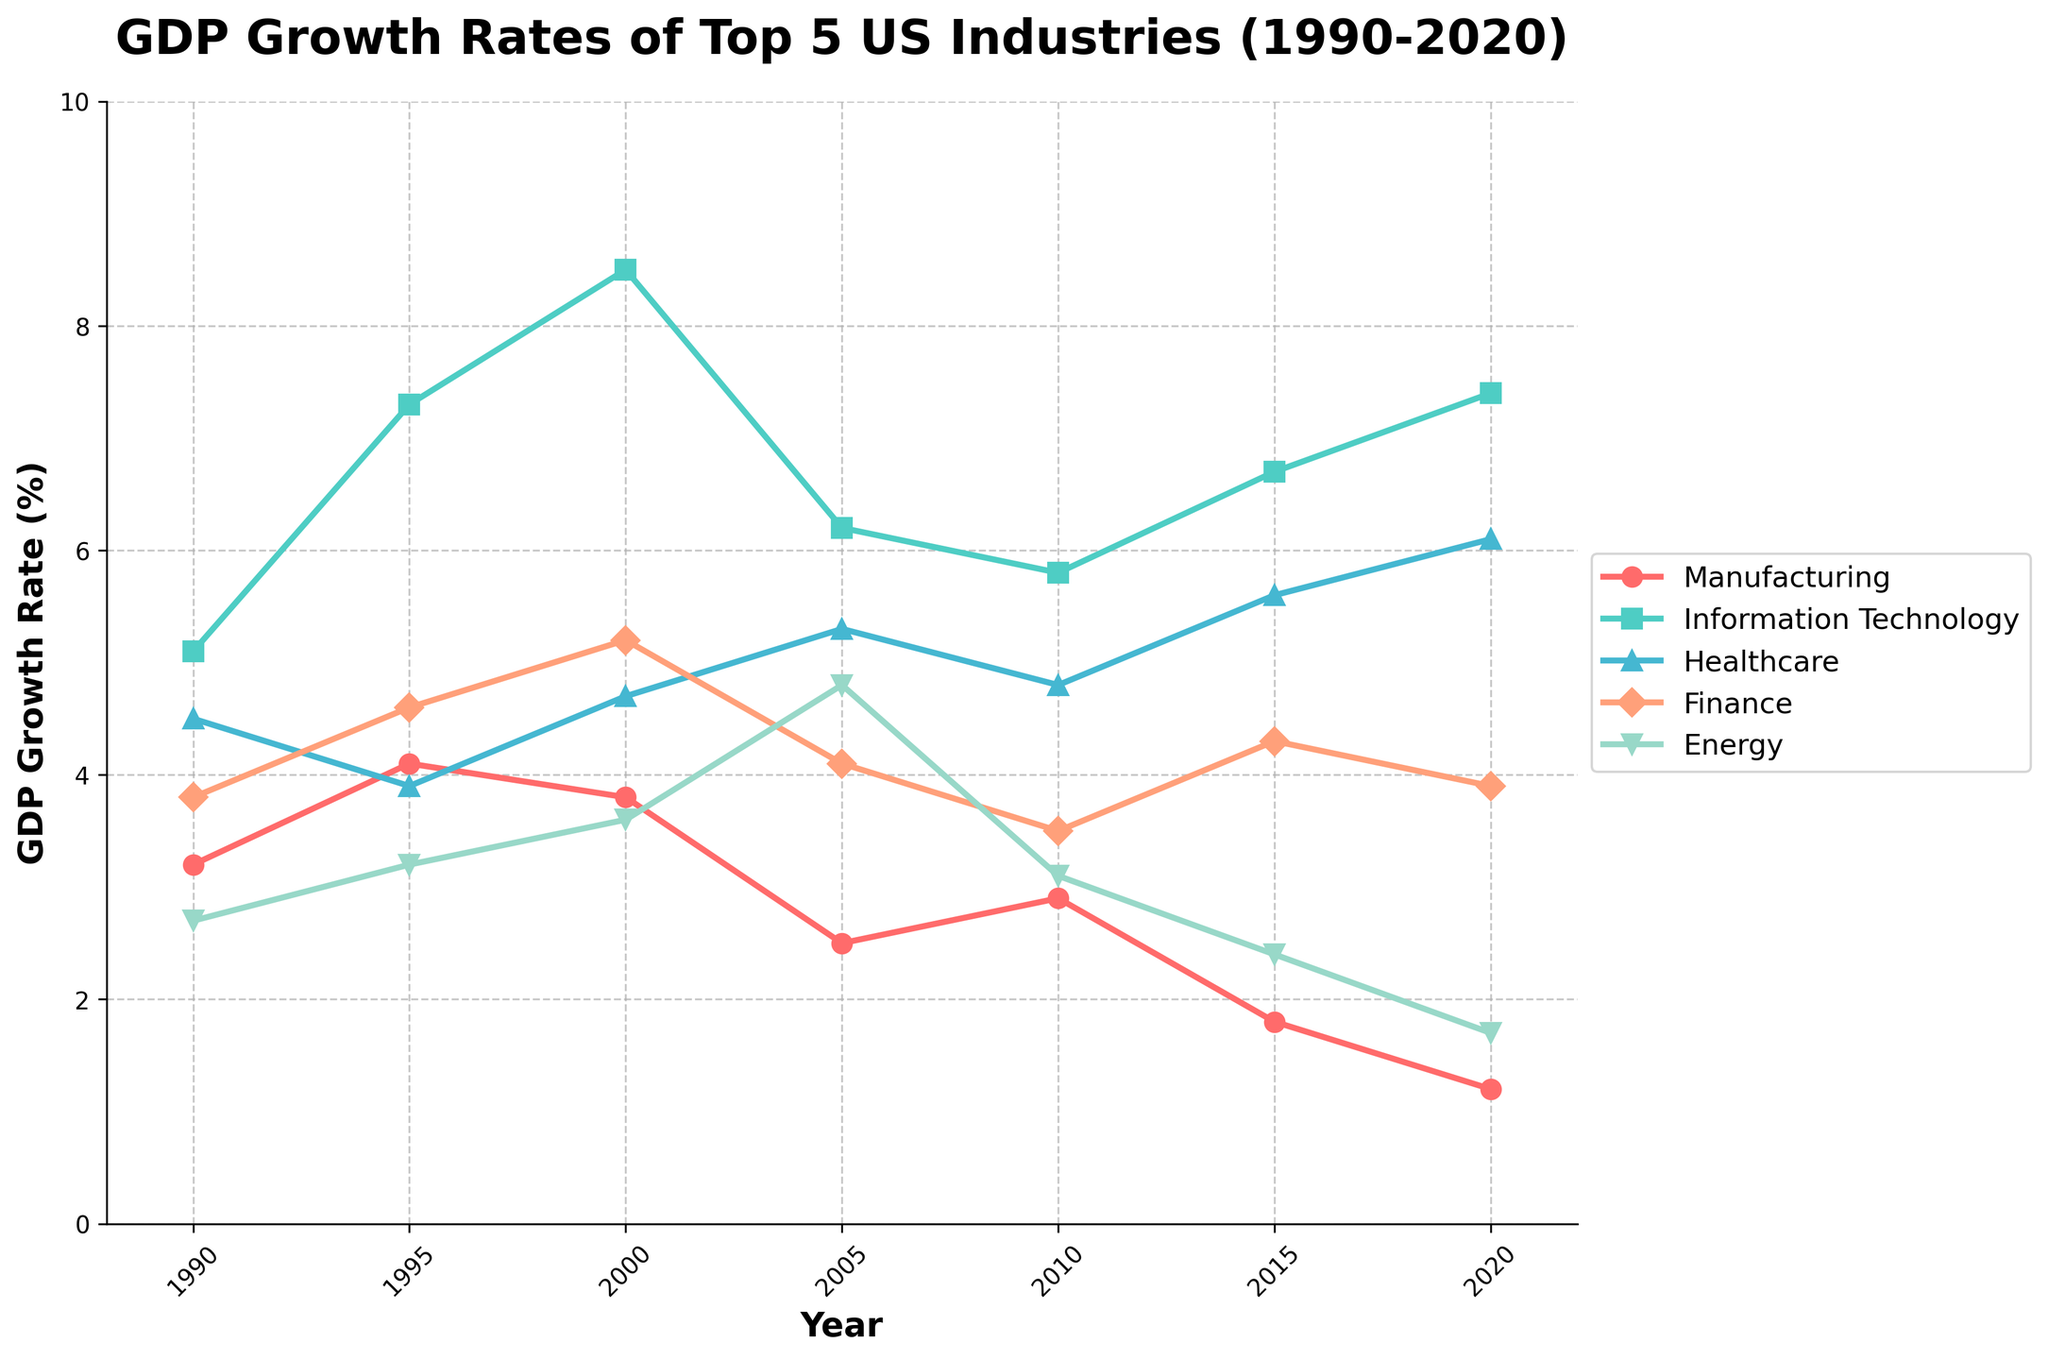What is the average GDP growth rate of the Healthcare industry from 1990 to 2020? To find the average, sum up the GDP growth rates of the Healthcare industry from 1990 to 2020 (4.5 + 3.9 + 4.7 + 5.3 + 4.8 + 5.6 + 6.1 = 34.9), then divide by the number of data points (7). So, 34.9 / 7 ≈ 4.99.
Answer: 4.99 Which industry shows the highest GDP growth rate in 2020? Look at the data for 2020 and compare the growth rates of all industries. The Information Technology industry has the highest growth rate at 7.4%.
Answer: Information Technology How does the GDP growth rate of the Manufacturing industry in 1990 compare to that in 2020? Compare the rates in the first and the last year for the Manufacturing industry. In 1990, it's 3.2%, and in 2020, it's 1.2%. The growth rate decreased by 2%.
Answer: Decreased by 2% What is the median GDP growth rate of the Finance industry from 1990 to 2020? Arrange the growth rates in ascending order (3.5, 3.8, 3.9, 4.1, 4.3, 4.6, 5.2) and find the middle value. The middle value is 4.1%.
Answer: 4.1 Between which consecutive years did the Energy industry experience the highest increase in GDP growth rate? Examine the given year's data to calculate the differences for consecutive years. The highest increase is between 2000 (3.6%) and 2005 (4.8%) which is 1.2%.
Answer: Between 2000 and 2005 Which industry has shown a relatively stable growth rate over the years? To find a stable growth rate, look for an industry where the changes in rates over the years are minimal. The Healthcare industry shows relatively stable growth rates, ranging between 3.9% and 6.1%.
Answer: Healthcare In what year did the GDP growth rate of Finance peak? Examine the Finance industry's growth rates across all years and identify the highest value. The peak is in the year 2000 with a rate of 5.2%.
Answer: 2000 How did the GDP growth rate of Information Technology change between 2000 and 2010? Compare the rates in 2000 (8.5%) and 2010 (5.8%) for the Information Technology industry. The growth rate decreased by 2.7%.
Answer: Decreased by 2.7% What is the total sum of the GDP growth rates for the Energy industry from 1990 to 2020? Add up all the data points for the Energy industry from 1990 to 2020 (2.7 + 3.2 + 3.6 + 4.8 + 3.1 + 2.4 + 1.7 = 21.5).
Answer: 21.5 Which industry had the lowest GDP growth rate in 2015? Compare the GDP growth rates of all industries in 2015. The Manufacturing industry has the lowest growth rate at 1.8%.
Answer: Manufacturing 